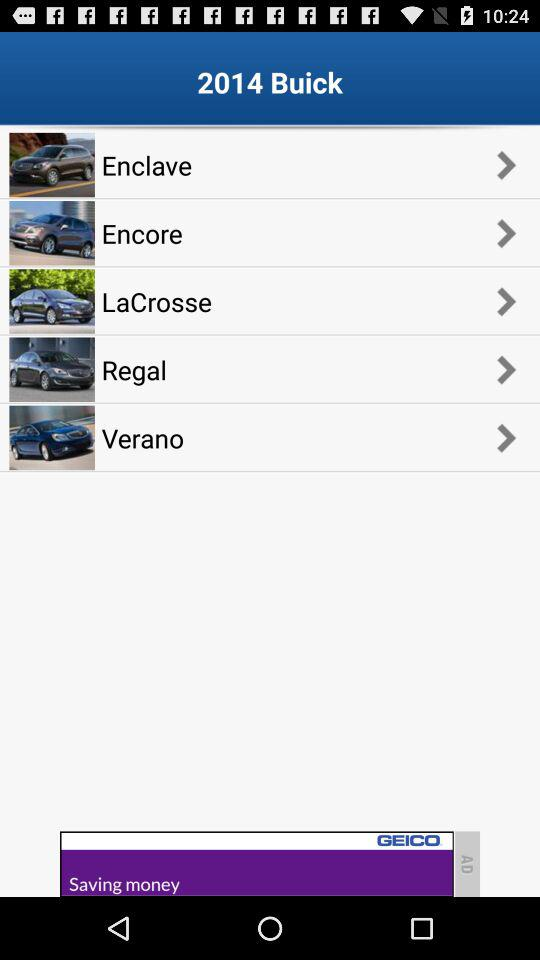How much is a "LaCrosse"?
When the provided information is insufficient, respond with <no answer>. <no answer> 